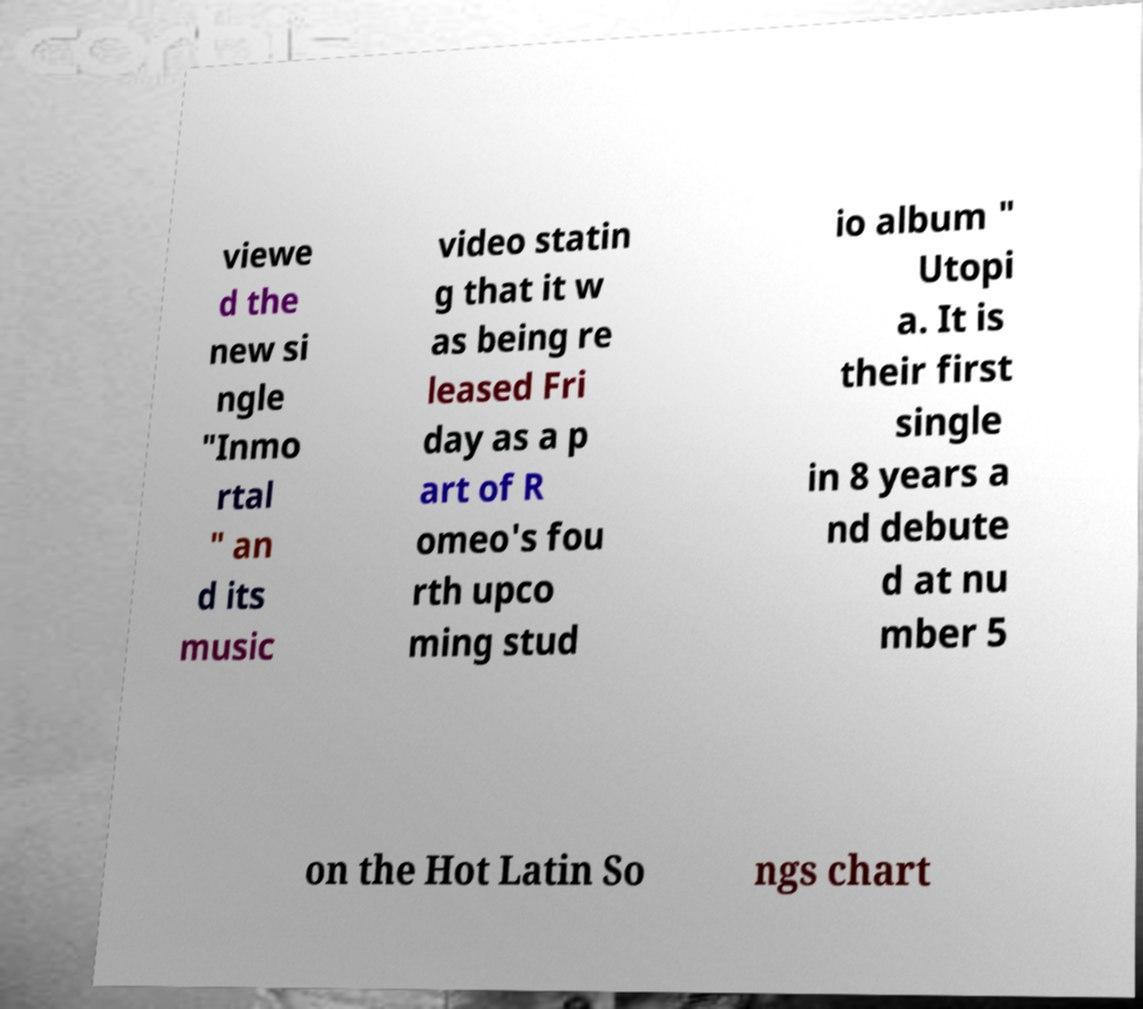I need the written content from this picture converted into text. Can you do that? viewe d the new si ngle "Inmo rtal " an d its music video statin g that it w as being re leased Fri day as a p art of R omeo's fou rth upco ming stud io album " Utopi a. It is their first single in 8 years a nd debute d at nu mber 5 on the Hot Latin So ngs chart 